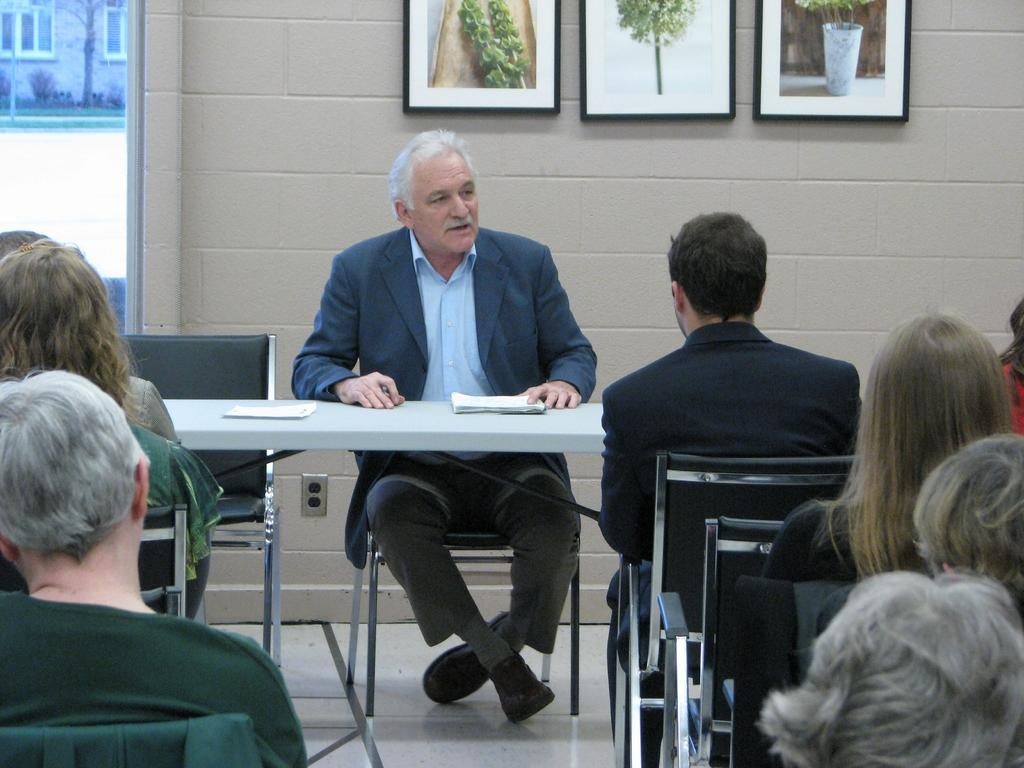What type of furniture is present in the image? There is a table and a chair in the image. What can be seen on the table? There are photo frames and a paper book on the table. Where was the image taken? The image was taken in a room. What are the people in the image doing? There are people sitting on chairs. Is there any liquid visible in the image? No, there is no liquid visible in the image. Can you tell me how many people are trying to join the group in the image? There is no indication of anyone trying to join the group in the image; the people sitting on chairs are already part of the group. 